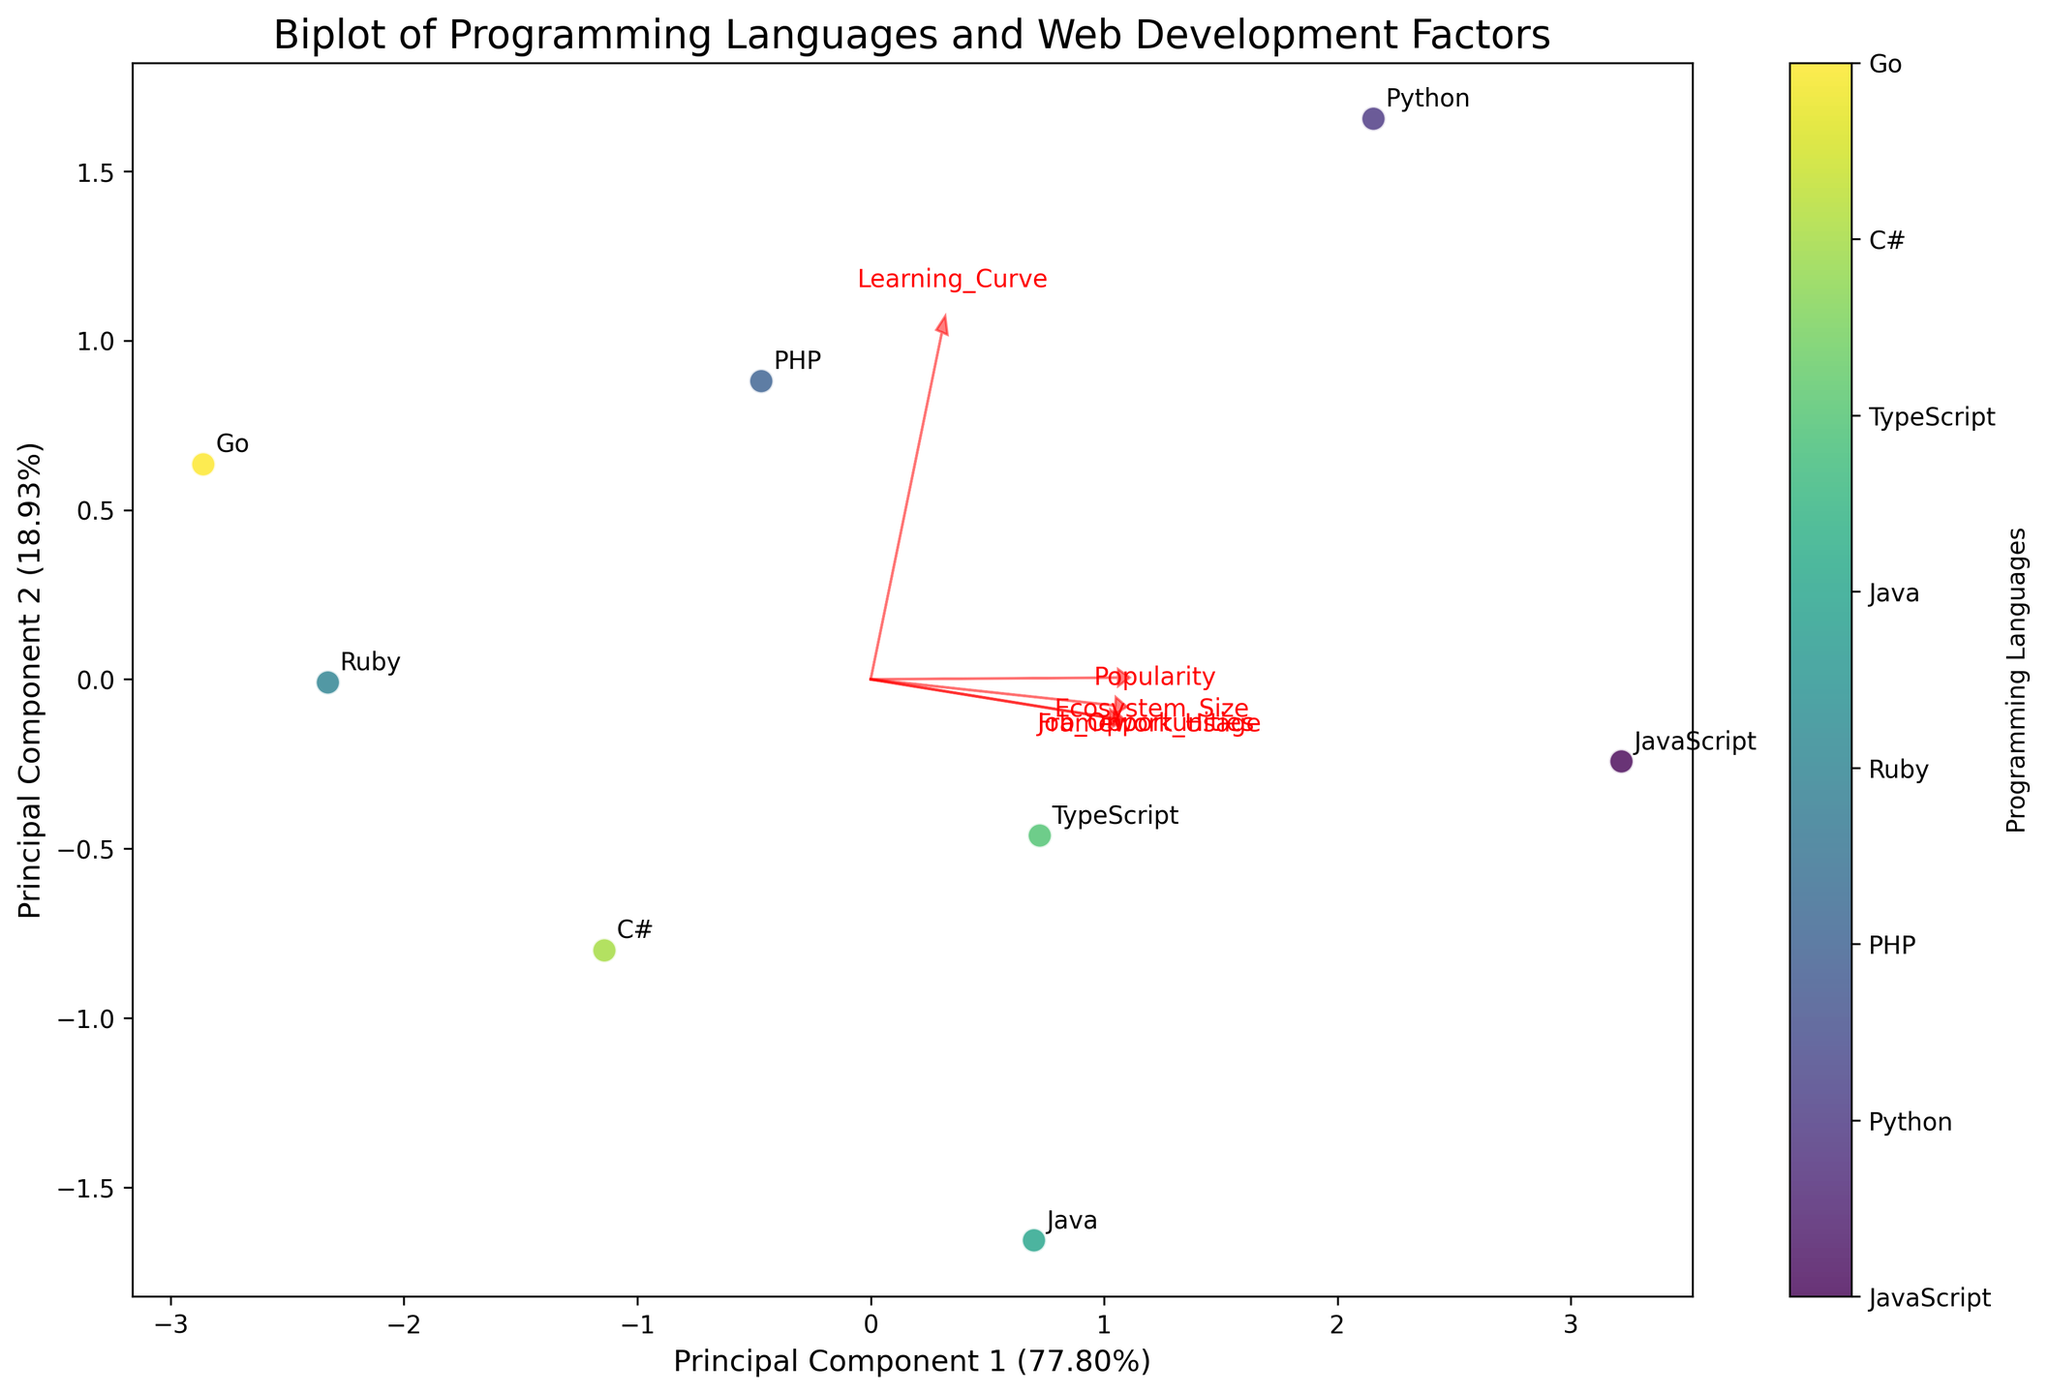How many programming languages are represented in the biplot? Count the number of data points (color-coded dots) each labeled with a distinct programming language name.
Answer: 8 Which programming language appears closest to the origin (0,0) in the plot? Observe the data points and identify the programming language that has coordinates closest to the origin in the biplot.
Answer: Go What does Principal Component 1 primarily represent? By analyzing the axis labels, loadings of the vectors, and how data points are spread along the x-axis, infer the key factor or combination of factors represented by Principal Component 1.
Answer: Job Opportunities and Framework Usage How does Python compare to JavaScript regarding Ecosystem Size? Look at the vector labeled "Ecosystem_Size" and compare the projection of the points for Python and JavaScript onto this vector.
Answer: Python is slightly lower Which programming language shows the highest Framework Usage? Identify the point that projects furthest along the vector labeled "Framework_Usage."
Answer: JavaScript Are there any programming languages that appear in the same quadrant? If yes, name a pair. By observing the positions of the points, check if any pairs of points fall into the same quadrant formed by the intersection of the x and y axes.
Answer: JavaScript and TypeScript Which axis explains more variance in the data? Compare the explained variance percentages labeled on the x-axis and y-axis to determine which axis, Principal Component 1 or Principal Component 2, accounts for more variability.
Answer: Principal Component 1 Which programming language is positioned farthest from Java? Measure the distance in the plot between the point labeled "Java" and the farthest point representing another programming language.
Answer: Ruby What feature significantly influences Principal Component 2? Examine the vectors perpendicular to the y-axis (Principal Component 2) and identify which feature has the longest arrow in that direction, indicating strong influence.
Answer: Learning Curve 